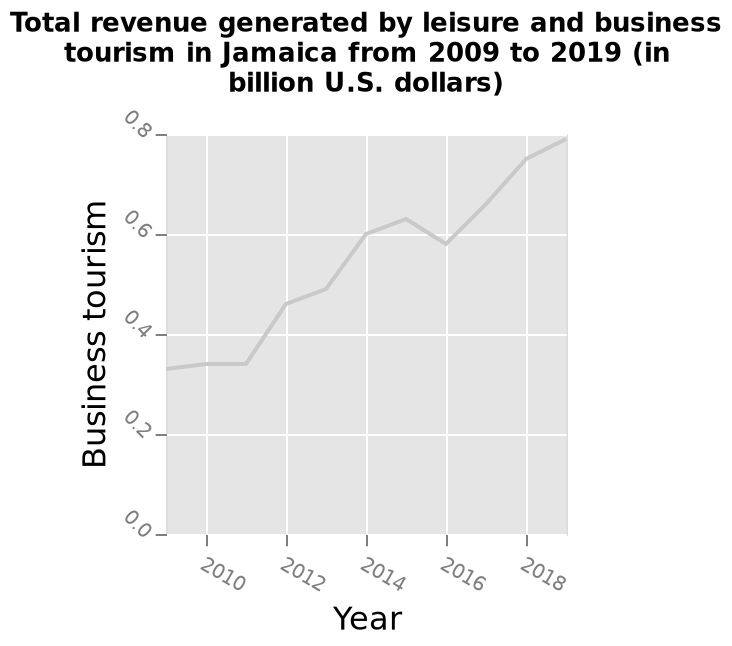<image>
In which unit is the total revenue measured? The total revenue is measured in billion U.S. dollars. What does the x-axis measure in the bar graph?  The x-axis measures the Year. 